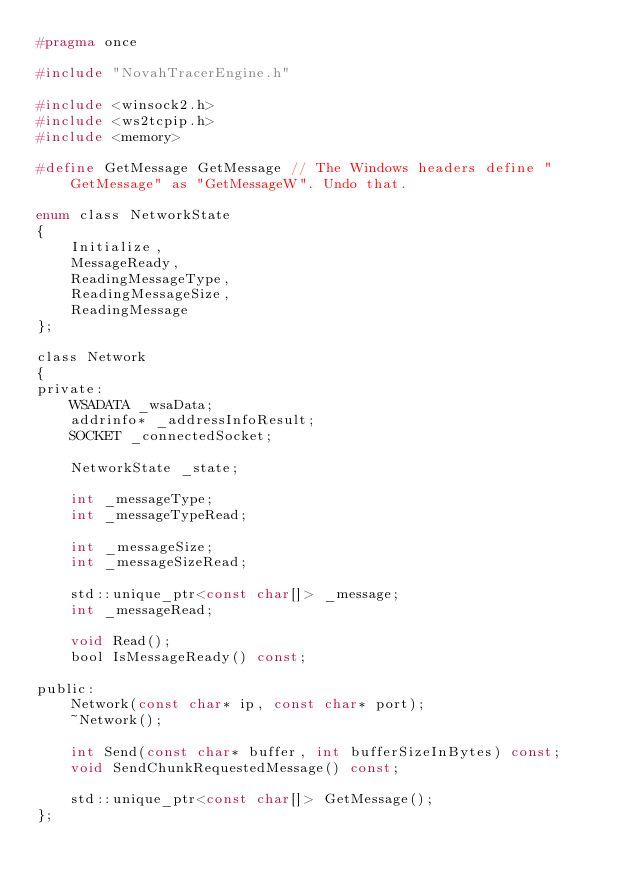<code> <loc_0><loc_0><loc_500><loc_500><_C_>#pragma once

#include "NovahTracerEngine.h"

#include <winsock2.h>
#include <ws2tcpip.h>
#include <memory>

#define GetMessage GetMessage // The Windows headers define "GetMessage" as "GetMessageW". Undo that.

enum class NetworkState
{
    Initialize,
    MessageReady,
    ReadingMessageType,
    ReadingMessageSize,
    ReadingMessage
};

class Network
{
private:
    WSADATA _wsaData;
    addrinfo* _addressInfoResult;
    SOCKET _connectedSocket;

    NetworkState _state;

    int _messageType;
    int _messageTypeRead;

    int _messageSize;
    int _messageSizeRead;

    std::unique_ptr<const char[]> _message;
    int _messageRead;

    void Read();
    bool IsMessageReady() const;

public:
    Network(const char* ip, const char* port);
    ~Network();

    int Send(const char* buffer, int bufferSizeInBytes) const;
    void SendChunkRequestedMessage() const;

    std::unique_ptr<const char[]> GetMessage();
};</code> 